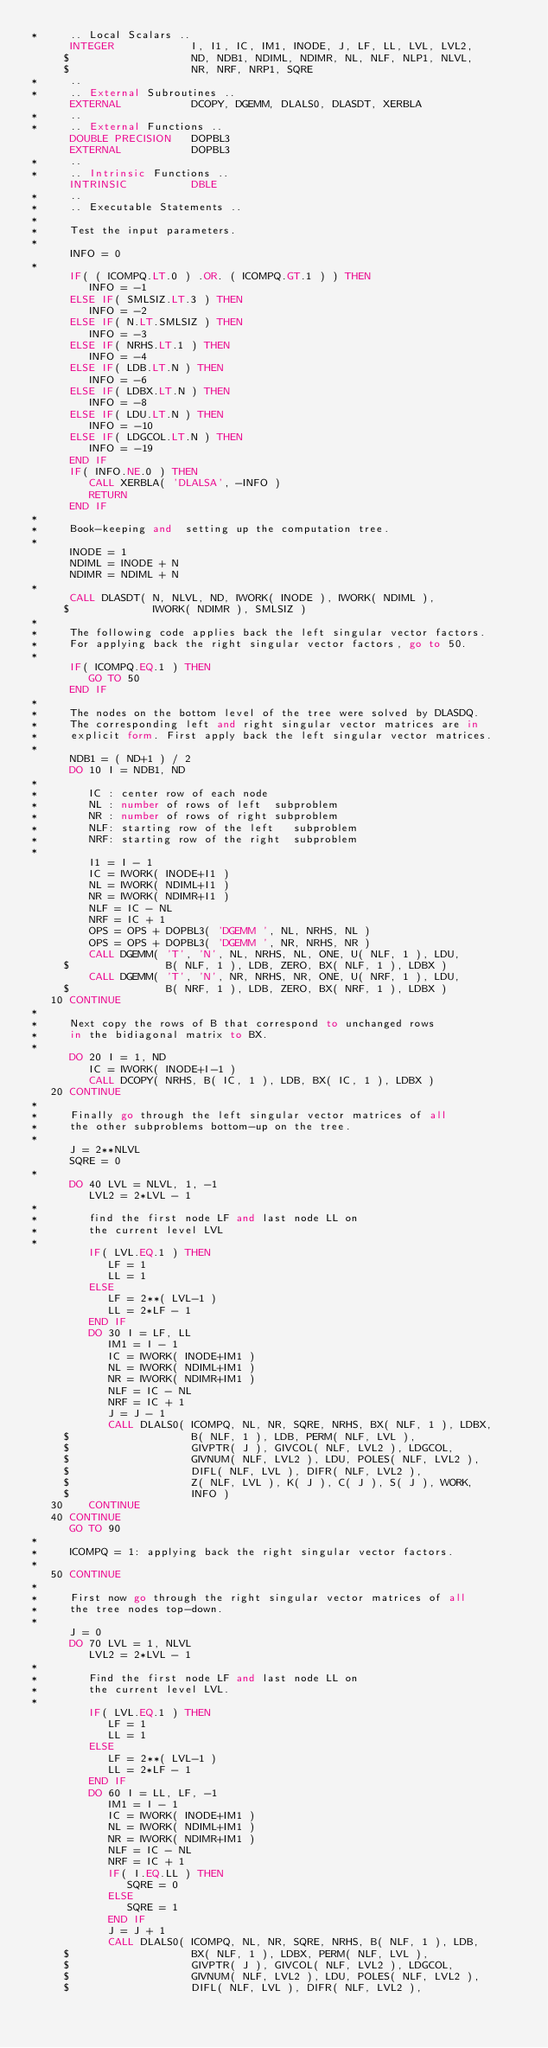<code> <loc_0><loc_0><loc_500><loc_500><_FORTRAN_>*     .. Local Scalars ..
      INTEGER            I, I1, IC, IM1, INODE, J, LF, LL, LVL, LVL2,
     $                   ND, NDB1, NDIML, NDIMR, NL, NLF, NLP1, NLVL,
     $                   NR, NRF, NRP1, SQRE
*     ..
*     .. External Subroutines ..
      EXTERNAL           DCOPY, DGEMM, DLALS0, DLASDT, XERBLA
*     ..
*     .. External Functions ..
      DOUBLE PRECISION   DOPBL3
      EXTERNAL           DOPBL3
*     ..
*     .. Intrinsic Functions ..
      INTRINSIC          DBLE 
*     ..
*     .. Executable Statements ..
*
*     Test the input parameters.
*
      INFO = 0
*
      IF( ( ICOMPQ.LT.0 ) .OR. ( ICOMPQ.GT.1 ) ) THEN
         INFO = -1
      ELSE IF( SMLSIZ.LT.3 ) THEN
         INFO = -2
      ELSE IF( N.LT.SMLSIZ ) THEN
         INFO = -3
      ELSE IF( NRHS.LT.1 ) THEN
         INFO = -4
      ELSE IF( LDB.LT.N ) THEN
         INFO = -6
      ELSE IF( LDBX.LT.N ) THEN
         INFO = -8
      ELSE IF( LDU.LT.N ) THEN
         INFO = -10
      ELSE IF( LDGCOL.LT.N ) THEN
         INFO = -19
      END IF
      IF( INFO.NE.0 ) THEN
         CALL XERBLA( 'DLALSA', -INFO )
         RETURN
      END IF
*
*     Book-keeping and  setting up the computation tree.
*
      INODE = 1
      NDIML = INODE + N
      NDIMR = NDIML + N
*
      CALL DLASDT( N, NLVL, ND, IWORK( INODE ), IWORK( NDIML ),
     $             IWORK( NDIMR ), SMLSIZ )
*
*     The following code applies back the left singular vector factors.
*     For applying back the right singular vector factors, go to 50.
*
      IF( ICOMPQ.EQ.1 ) THEN
         GO TO 50
      END IF
*
*     The nodes on the bottom level of the tree were solved by DLASDQ.
*     The corresponding left and right singular vector matrices are in
*     explicit form. First apply back the left singular vector matrices.
*
      NDB1 = ( ND+1 ) / 2
      DO 10 I = NDB1, ND
*
*        IC : center row of each node
*        NL : number of rows of left  subproblem
*        NR : number of rows of right subproblem
*        NLF: starting row of the left   subproblem
*        NRF: starting row of the right  subproblem
*
         I1 = I - 1
         IC = IWORK( INODE+I1 )
         NL = IWORK( NDIML+I1 )
         NR = IWORK( NDIMR+I1 )
         NLF = IC - NL
         NRF = IC + 1
         OPS = OPS + DOPBL3( 'DGEMM ', NL, NRHS, NL ) 
         OPS = OPS + DOPBL3( 'DGEMM ', NR, NRHS, NR ) 
         CALL DGEMM( 'T', 'N', NL, NRHS, NL, ONE, U( NLF, 1 ), LDU,
     $               B( NLF, 1 ), LDB, ZERO, BX( NLF, 1 ), LDBX )
         CALL DGEMM( 'T', 'N', NR, NRHS, NR, ONE, U( NRF, 1 ), LDU,
     $               B( NRF, 1 ), LDB, ZERO, BX( NRF, 1 ), LDBX )
   10 CONTINUE
*
*     Next copy the rows of B that correspond to unchanged rows
*     in the bidiagonal matrix to BX.
*
      DO 20 I = 1, ND
         IC = IWORK( INODE+I-1 )
         CALL DCOPY( NRHS, B( IC, 1 ), LDB, BX( IC, 1 ), LDBX )
   20 CONTINUE
*
*     Finally go through the left singular vector matrices of all
*     the other subproblems bottom-up on the tree.
*
      J = 2**NLVL
      SQRE = 0
*
      DO 40 LVL = NLVL, 1, -1
         LVL2 = 2*LVL - 1
*
*        find the first node LF and last node LL on
*        the current level LVL
*
         IF( LVL.EQ.1 ) THEN
            LF = 1
            LL = 1
         ELSE
            LF = 2**( LVL-1 )
            LL = 2*LF - 1
         END IF
         DO 30 I = LF, LL
            IM1 = I - 1
            IC = IWORK( INODE+IM1 )
            NL = IWORK( NDIML+IM1 )
            NR = IWORK( NDIMR+IM1 )
            NLF = IC - NL
            NRF = IC + 1
            J = J - 1
            CALL DLALS0( ICOMPQ, NL, NR, SQRE, NRHS, BX( NLF, 1 ), LDBX,
     $                   B( NLF, 1 ), LDB, PERM( NLF, LVL ),
     $                   GIVPTR( J ), GIVCOL( NLF, LVL2 ), LDGCOL,
     $                   GIVNUM( NLF, LVL2 ), LDU, POLES( NLF, LVL2 ),
     $                   DIFL( NLF, LVL ), DIFR( NLF, LVL2 ),
     $                   Z( NLF, LVL ), K( J ), C( J ), S( J ), WORK,
     $                   INFO )
   30    CONTINUE
   40 CONTINUE
      GO TO 90
*
*     ICOMPQ = 1: applying back the right singular vector factors.
*
   50 CONTINUE
*
*     First now go through the right singular vector matrices of all
*     the tree nodes top-down.
*
      J = 0
      DO 70 LVL = 1, NLVL
         LVL2 = 2*LVL - 1
*
*        Find the first node LF and last node LL on
*        the current level LVL.
*
         IF( LVL.EQ.1 ) THEN
            LF = 1
            LL = 1
         ELSE
            LF = 2**( LVL-1 )
            LL = 2*LF - 1
         END IF
         DO 60 I = LL, LF, -1
            IM1 = I - 1
            IC = IWORK( INODE+IM1 )
            NL = IWORK( NDIML+IM1 )
            NR = IWORK( NDIMR+IM1 )
            NLF = IC - NL
            NRF = IC + 1
            IF( I.EQ.LL ) THEN
               SQRE = 0
            ELSE
               SQRE = 1
            END IF
            J = J + 1
            CALL DLALS0( ICOMPQ, NL, NR, SQRE, NRHS, B( NLF, 1 ), LDB,
     $                   BX( NLF, 1 ), LDBX, PERM( NLF, LVL ),
     $                   GIVPTR( J ), GIVCOL( NLF, LVL2 ), LDGCOL,
     $                   GIVNUM( NLF, LVL2 ), LDU, POLES( NLF, LVL2 ),
     $                   DIFL( NLF, LVL ), DIFR( NLF, LVL2 ),</code> 